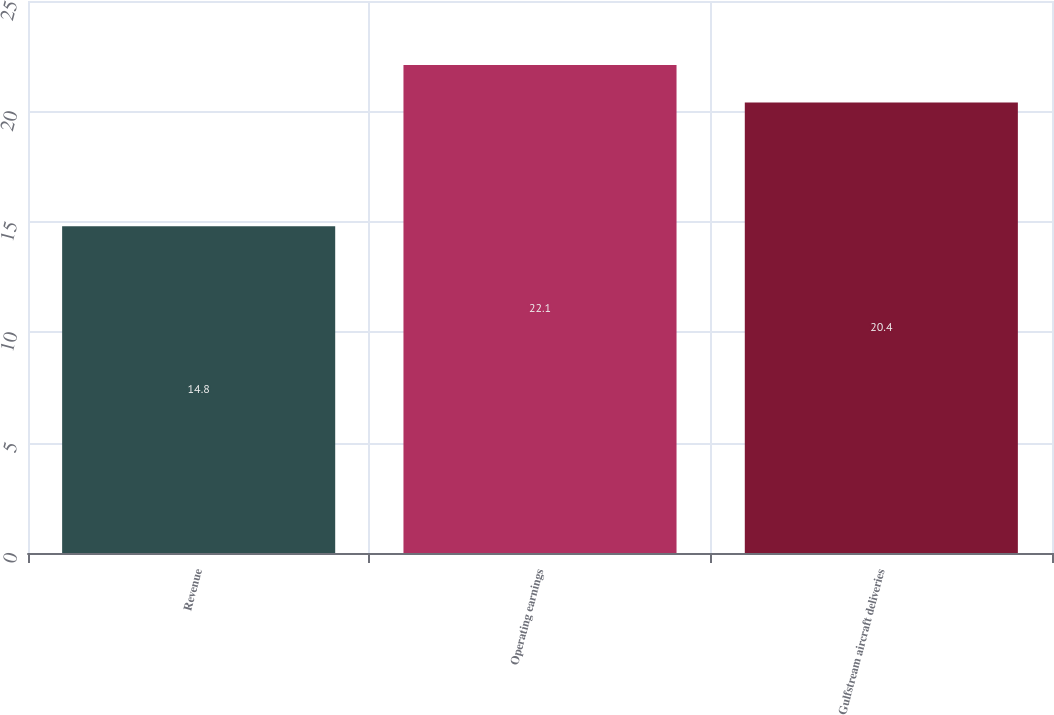<chart> <loc_0><loc_0><loc_500><loc_500><bar_chart><fcel>Revenue<fcel>Operating earnings<fcel>Gulfstream aircraft deliveries<nl><fcel>14.8<fcel>22.1<fcel>20.4<nl></chart> 